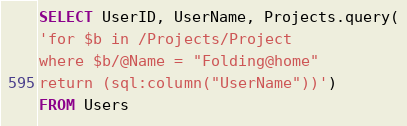<code> <loc_0><loc_0><loc_500><loc_500><_SQL_>SELECT UserID, UserName, Projects.query(
'for $b in /Projects/Project
where $b/@Name = "Folding@home"
return (sql:column("UserName"))')
FROM Users</code> 